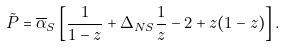Convert formula to latex. <formula><loc_0><loc_0><loc_500><loc_500>\tilde { P } = { \overline { \alpha } } _ { S } \left [ \frac { 1 } { 1 - z } + \Delta _ { N S } \frac { 1 } { z } - 2 + z ( 1 - z ) \right ] .</formula> 